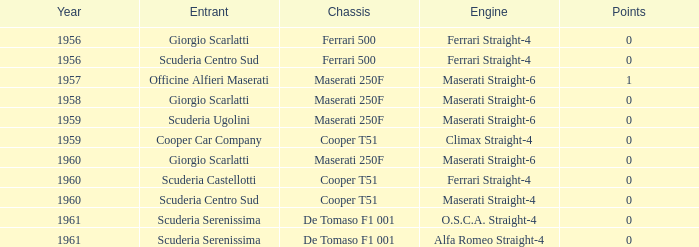How many points for the cooper car company after 1959? None. I'm looking to parse the entire table for insights. Could you assist me with that? {'header': ['Year', 'Entrant', 'Chassis', 'Engine', 'Points'], 'rows': [['1956', 'Giorgio Scarlatti', 'Ferrari 500', 'Ferrari Straight-4', '0'], ['1956', 'Scuderia Centro Sud', 'Ferrari 500', 'Ferrari Straight-4', '0'], ['1957', 'Officine Alfieri Maserati', 'Maserati 250F', 'Maserati Straight-6', '1'], ['1958', 'Giorgio Scarlatti', 'Maserati 250F', 'Maserati Straight-6', '0'], ['1959', 'Scuderia Ugolini', 'Maserati 250F', 'Maserati Straight-6', '0'], ['1959', 'Cooper Car Company', 'Cooper T51', 'Climax Straight-4', '0'], ['1960', 'Giorgio Scarlatti', 'Maserati 250F', 'Maserati Straight-6', '0'], ['1960', 'Scuderia Castellotti', 'Cooper T51', 'Ferrari Straight-4', '0'], ['1960', 'Scuderia Centro Sud', 'Cooper T51', 'Maserati Straight-4', '0'], ['1961', 'Scuderia Serenissima', 'De Tomaso F1 001', 'O.S.C.A. Straight-4', '0'], ['1961', 'Scuderia Serenissima', 'De Tomaso F1 001', 'Alfa Romeo Straight-4', '0']]} 